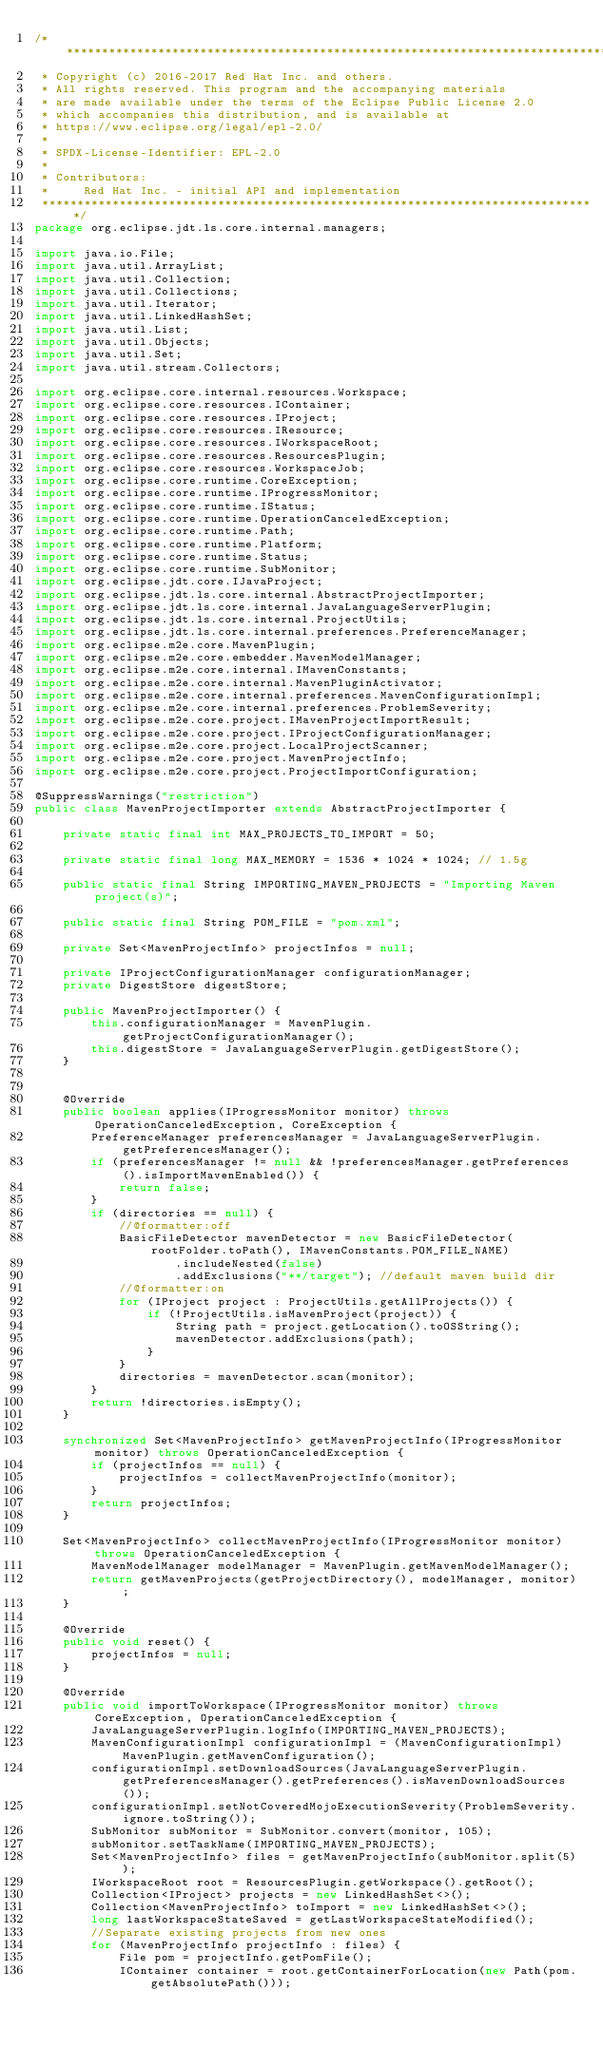Convert code to text. <code><loc_0><loc_0><loc_500><loc_500><_Java_>/*******************************************************************************
 * Copyright (c) 2016-2017 Red Hat Inc. and others.
 * All rights reserved. This program and the accompanying materials
 * are made available under the terms of the Eclipse Public License 2.0
 * which accompanies this distribution, and is available at
 * https://www.eclipse.org/legal/epl-2.0/
 *
 * SPDX-License-Identifier: EPL-2.0
 *
 * Contributors:
 *     Red Hat Inc. - initial API and implementation
 *******************************************************************************/
package org.eclipse.jdt.ls.core.internal.managers;

import java.io.File;
import java.util.ArrayList;
import java.util.Collection;
import java.util.Collections;
import java.util.Iterator;
import java.util.LinkedHashSet;
import java.util.List;
import java.util.Objects;
import java.util.Set;
import java.util.stream.Collectors;

import org.eclipse.core.internal.resources.Workspace;
import org.eclipse.core.resources.IContainer;
import org.eclipse.core.resources.IProject;
import org.eclipse.core.resources.IResource;
import org.eclipse.core.resources.IWorkspaceRoot;
import org.eclipse.core.resources.ResourcesPlugin;
import org.eclipse.core.resources.WorkspaceJob;
import org.eclipse.core.runtime.CoreException;
import org.eclipse.core.runtime.IProgressMonitor;
import org.eclipse.core.runtime.IStatus;
import org.eclipse.core.runtime.OperationCanceledException;
import org.eclipse.core.runtime.Path;
import org.eclipse.core.runtime.Platform;
import org.eclipse.core.runtime.Status;
import org.eclipse.core.runtime.SubMonitor;
import org.eclipse.jdt.core.IJavaProject;
import org.eclipse.jdt.ls.core.internal.AbstractProjectImporter;
import org.eclipse.jdt.ls.core.internal.JavaLanguageServerPlugin;
import org.eclipse.jdt.ls.core.internal.ProjectUtils;
import org.eclipse.jdt.ls.core.internal.preferences.PreferenceManager;
import org.eclipse.m2e.core.MavenPlugin;
import org.eclipse.m2e.core.embedder.MavenModelManager;
import org.eclipse.m2e.core.internal.IMavenConstants;
import org.eclipse.m2e.core.internal.MavenPluginActivator;
import org.eclipse.m2e.core.internal.preferences.MavenConfigurationImpl;
import org.eclipse.m2e.core.internal.preferences.ProblemSeverity;
import org.eclipse.m2e.core.project.IMavenProjectImportResult;
import org.eclipse.m2e.core.project.IProjectConfigurationManager;
import org.eclipse.m2e.core.project.LocalProjectScanner;
import org.eclipse.m2e.core.project.MavenProjectInfo;
import org.eclipse.m2e.core.project.ProjectImportConfiguration;

@SuppressWarnings("restriction")
public class MavenProjectImporter extends AbstractProjectImporter {

	private static final int MAX_PROJECTS_TO_IMPORT = 50;

	private static final long MAX_MEMORY = 1536 * 1024 * 1024; // 1.5g

	public static final String IMPORTING_MAVEN_PROJECTS = "Importing Maven project(s)";

	public static final String POM_FILE = "pom.xml";

	private Set<MavenProjectInfo> projectInfos = null;

	private IProjectConfigurationManager configurationManager;
	private DigestStore digestStore;

	public MavenProjectImporter() {
		this.configurationManager = MavenPlugin.getProjectConfigurationManager();
		this.digestStore = JavaLanguageServerPlugin.getDigestStore();
	}


	@Override
	public boolean applies(IProgressMonitor monitor) throws OperationCanceledException, CoreException {
		PreferenceManager preferencesManager = JavaLanguageServerPlugin.getPreferencesManager();
		if (preferencesManager != null && !preferencesManager.getPreferences().isImportMavenEnabled()) {
			return false;
		}
		if (directories == null) {
			//@formatter:off
			BasicFileDetector mavenDetector = new BasicFileDetector(rootFolder.toPath(), IMavenConstants.POM_FILE_NAME)
					.includeNested(false)
					.addExclusions("**/target"); //default maven build dir
			//@formatter:on
			for (IProject project : ProjectUtils.getAllProjects()) {
				if (!ProjectUtils.isMavenProject(project)) {
					String path = project.getLocation().toOSString();
					mavenDetector.addExclusions(path);
				}
			}
			directories = mavenDetector.scan(monitor);
		}
		return !directories.isEmpty();
	}

	synchronized Set<MavenProjectInfo> getMavenProjectInfo(IProgressMonitor monitor) throws OperationCanceledException {
		if (projectInfos == null) {
			projectInfos = collectMavenProjectInfo(monitor);
		}
		return projectInfos;
	}

	Set<MavenProjectInfo> collectMavenProjectInfo(IProgressMonitor monitor) throws OperationCanceledException {
		MavenModelManager modelManager = MavenPlugin.getMavenModelManager();
		return getMavenProjects(getProjectDirectory(), modelManager, monitor);
	}

	@Override
	public void reset() {
		projectInfos = null;
	}

	@Override
	public void importToWorkspace(IProgressMonitor monitor) throws CoreException, OperationCanceledException {
		JavaLanguageServerPlugin.logInfo(IMPORTING_MAVEN_PROJECTS);
		MavenConfigurationImpl configurationImpl = (MavenConfigurationImpl)MavenPlugin.getMavenConfiguration();
		configurationImpl.setDownloadSources(JavaLanguageServerPlugin.getPreferencesManager().getPreferences().isMavenDownloadSources());
		configurationImpl.setNotCoveredMojoExecutionSeverity(ProblemSeverity.ignore.toString());
		SubMonitor subMonitor = SubMonitor.convert(monitor, 105);
		subMonitor.setTaskName(IMPORTING_MAVEN_PROJECTS);
		Set<MavenProjectInfo> files = getMavenProjectInfo(subMonitor.split(5));
		IWorkspaceRoot root = ResourcesPlugin.getWorkspace().getRoot();
		Collection<IProject> projects = new LinkedHashSet<>();
		Collection<MavenProjectInfo> toImport = new LinkedHashSet<>();
		long lastWorkspaceStateSaved = getLastWorkspaceStateModified();
		//Separate existing projects from new ones
		for (MavenProjectInfo projectInfo : files) {
			File pom = projectInfo.getPomFile();
			IContainer container = root.getContainerForLocation(new Path(pom.getAbsolutePath()));</code> 